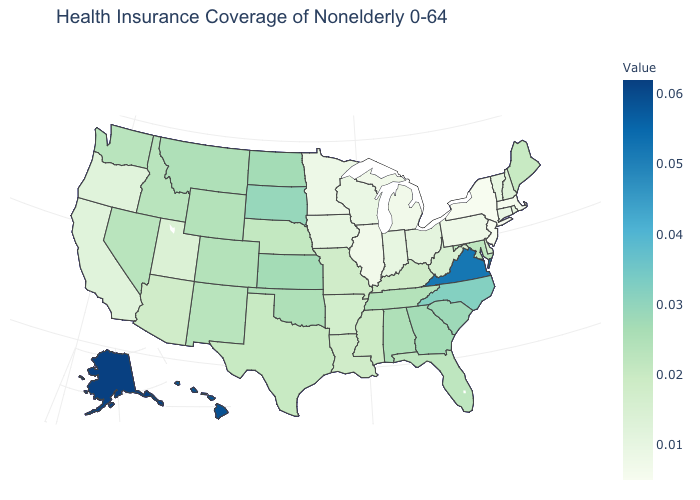Which states have the highest value in the USA?
Quick response, please. Alaska. Does New Jersey have the lowest value in the USA?
Short answer required. Yes. Does New York have the lowest value in the USA?
Concise answer only. Yes. Does Washington have a lower value than Hawaii?
Be succinct. Yes. Which states hav the highest value in the Northeast?
Keep it brief. Maine. 